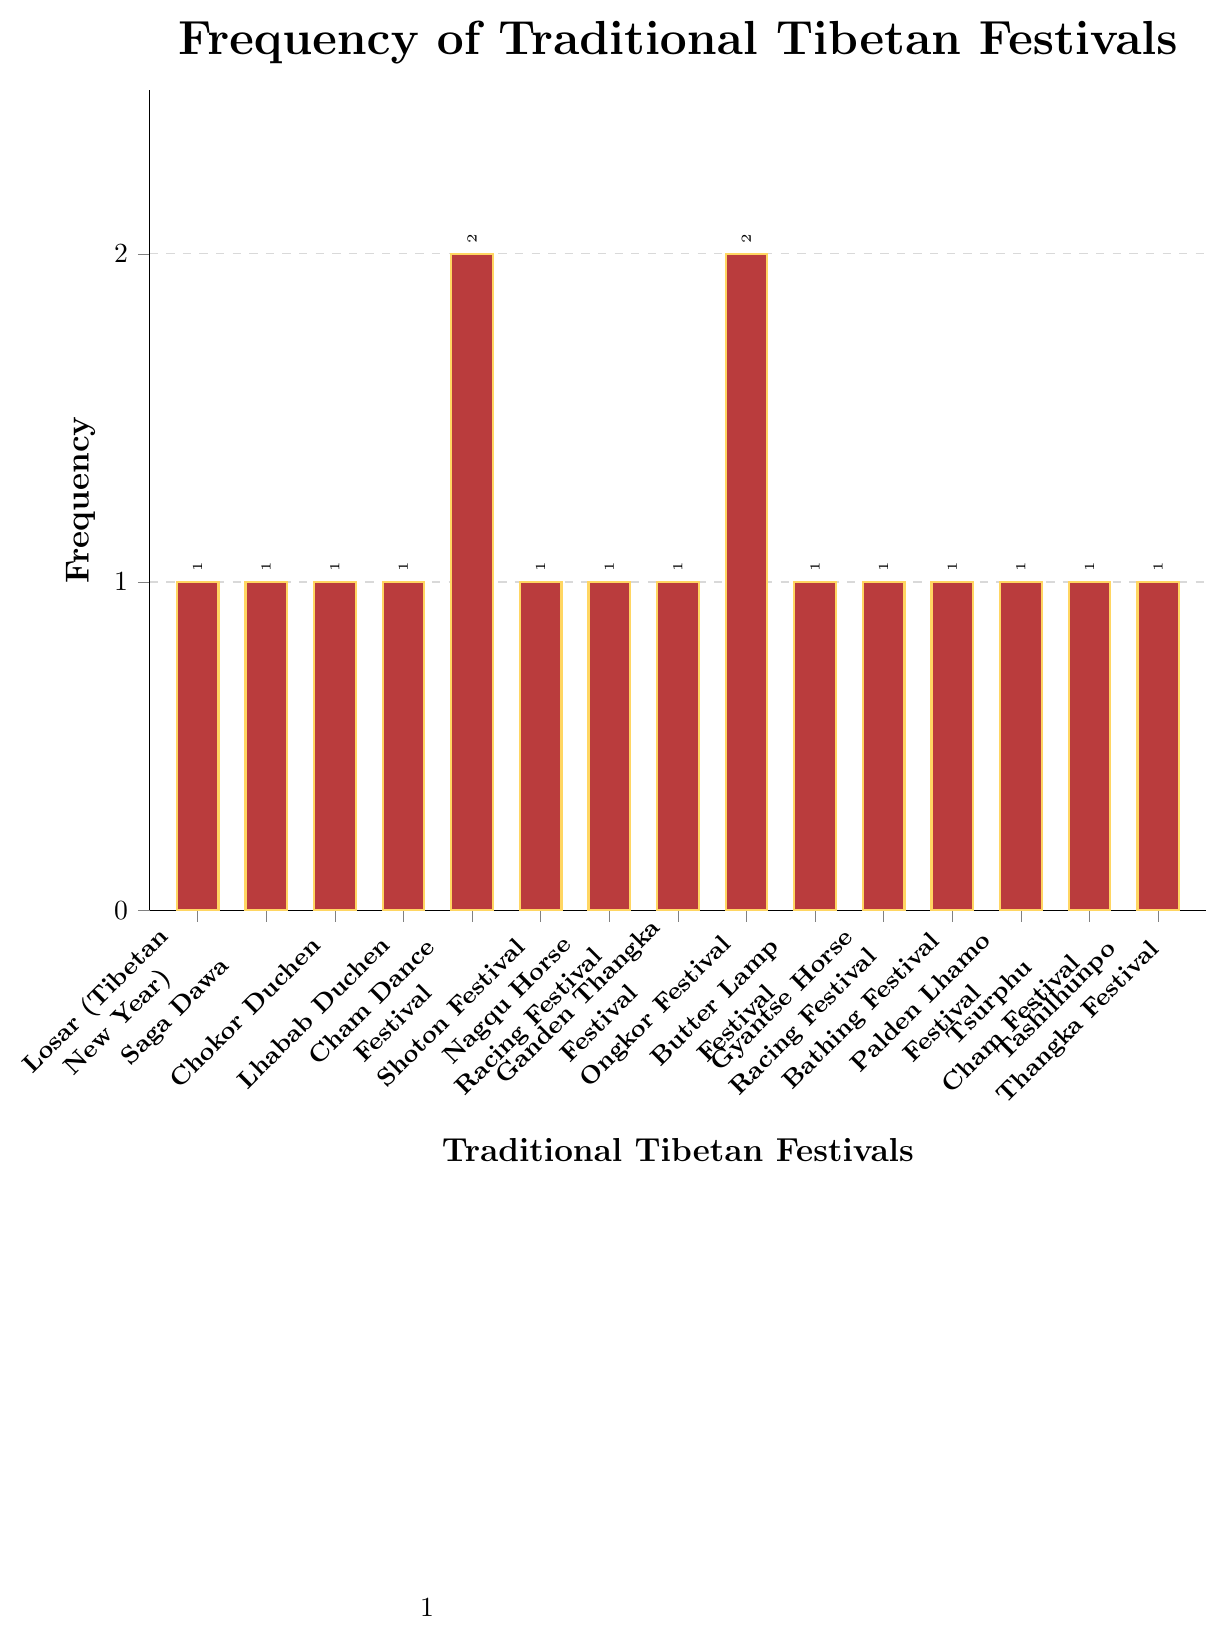What is the total frequency of festivals celebrated twice a year? Identify the festivals celebrated twice (Cham Dance Festival and Ongkor Festival) and sum their frequencies (2 + 2)
Answer: 4 Which festival has the highest frequency? Observe the heights of the bars to determine that Cham Dance Festival and Ongkor Festival are both celebrated twice, which is the highest frequency in the chart
Answer: Cham Dance Festival and Ongkor Festival Are most of the festivals celebrated once or twice a year? Count the number of festivals with a frequency of 1 and compare it to the number celebrated twice. There are 13 festivals with a frequency of 1 and 2 festivals with a frequency of 2
Answer: Once What is the combined frequency of Losar (Tibetan New Year), Saga Dawa, and Chokor Duchen? Sum the frequencies for Losar (1), Saga Dawa (1), and Chokor Duchen (1). The combined frequency is (1 + 1 + 1)
Answer: 3 Compare the frequency of the Cham Dance Festival to the Ganden Thangka Festival. Which one is celebrated more often? Cham Dance Festival has a frequency of 2 while Ganden Thangka Festival has a frequency of 1. Therefore, Cham Dance Festival is celebrated more often
Answer: Cham Dance Festival What is the average frequency of all the festivals? Add up all the frequencies (1+1+1+1+2+1+1+1+2+1+1+1+1+1+1 = 17) and divide by the number of festivals (15). The average frequency is 17/15
Answer: 1.13 How does the frequency of the Butter Lamp Festival compare to the Tashilhunpo Thangka Festival? Both Butter Lamp Festival and Tashilhunpo Thangka Festival have a frequency of 1, making them equally celebrated
Answer: Equal Which festivals have the same frequency as the Palden Lhamo Festival? Identify the frequency of the Palden Lhamo Festival (1) and list other festivals with the same frequency: Losar, Saga Dawa, Chokor Duchen, Lhabab Duchen, Shoton Festival, Nagqu Horse Racing Festival, Ganden Thangka Festival, Butter Lamp Festival, Gyantse Horse Racing Festival, Bathing Festival, Tsurphu Cham Festival, and Tashilhunpo Thangka Festival
Answer: Losar, Saga Dawa, Chokor Duchen, Lhabab Duchen, Shoton Festival, Nagqu Horse Racing Festival, Ganden Thangka Festival, Butter Lamp Festival, Gyantse Horse Racing Festival, Bathing Festival, Tsurphu Cham Festival, Tashilhunpo Thangka Festival What is the frequency range of the traditional Tibetan festivals? Calculate the range by subtracting the smallest frequency (1) from the largest frequency (2): (2 - 1)
Answer: 1 